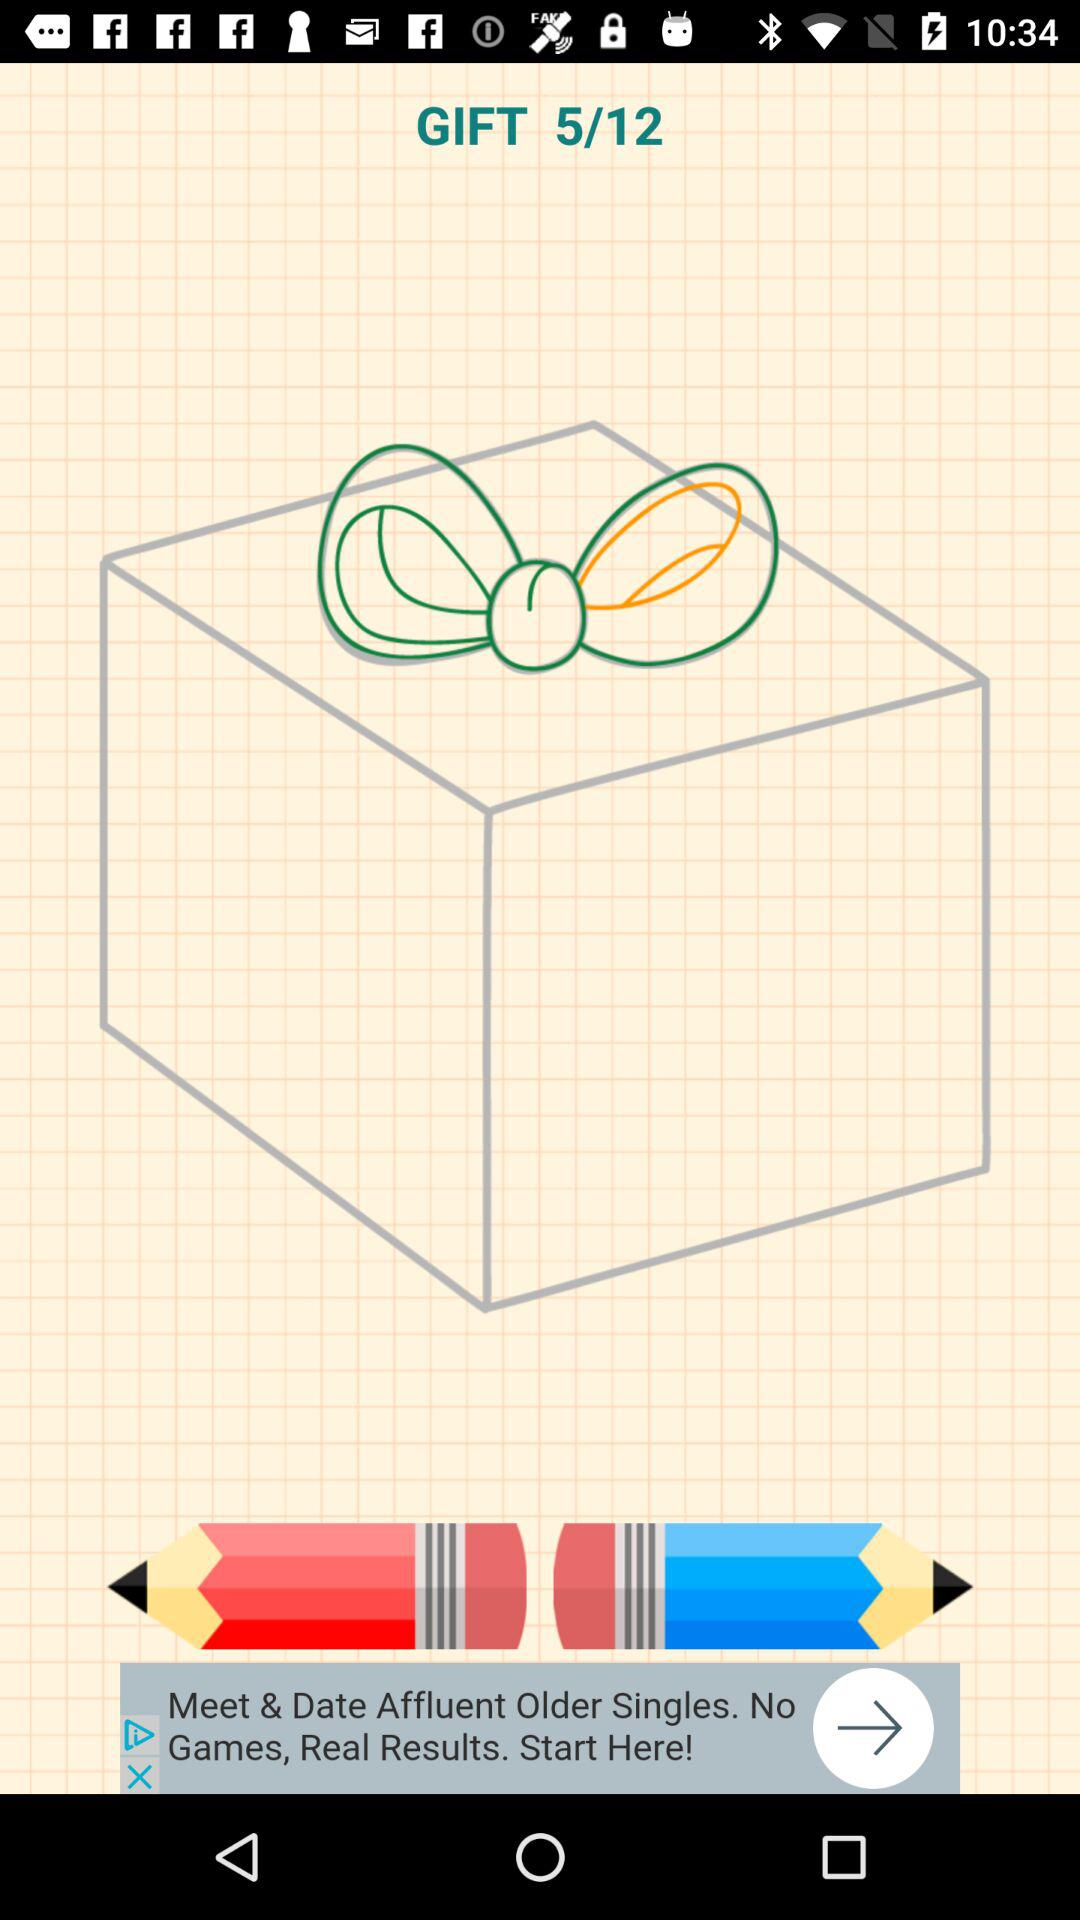At what image am I now? You are now on image 5. 